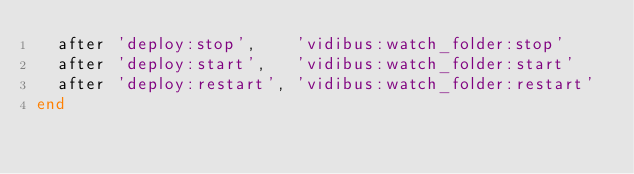<code> <loc_0><loc_0><loc_500><loc_500><_Ruby_>  after 'deploy:stop',    'vidibus:watch_folder:stop'
  after 'deploy:start',   'vidibus:watch_folder:start'
  after 'deploy:restart', 'vidibus:watch_folder:restart'
end
</code> 